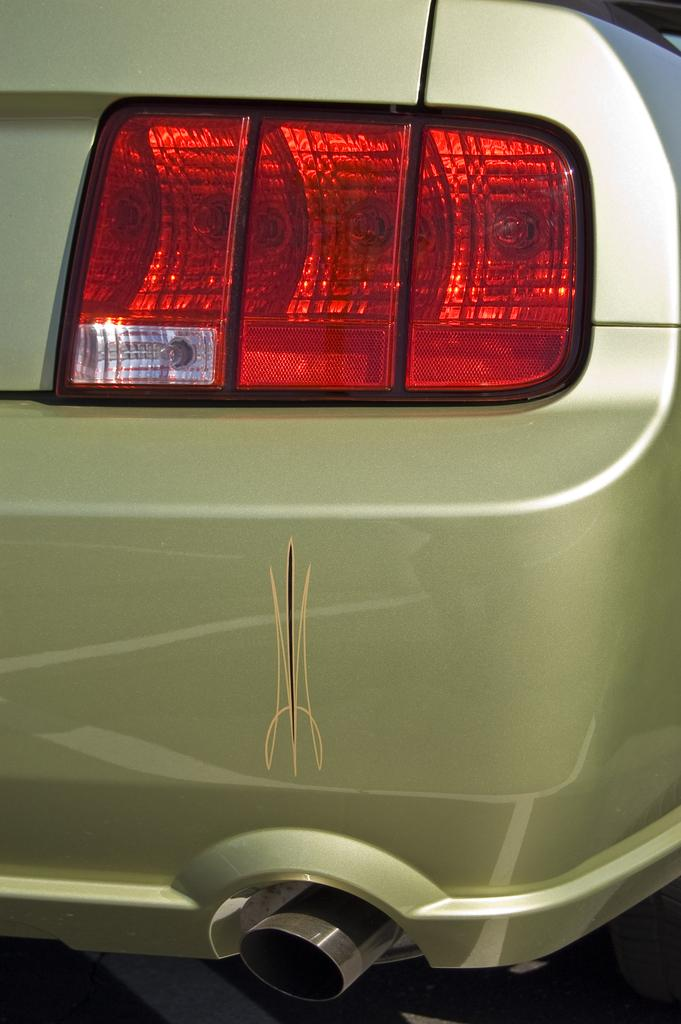What part of a car is shown in the image? The image contains the back area of a car. What can be seen in the back area of the car? There is a red light in the back area of the car. What type of coat is being worn by the car in the image? There is no coat present in the image, as it features the back area of a car with a red light. 